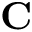Convert formula to latex. <formula><loc_0><loc_0><loc_500><loc_500>C</formula> 